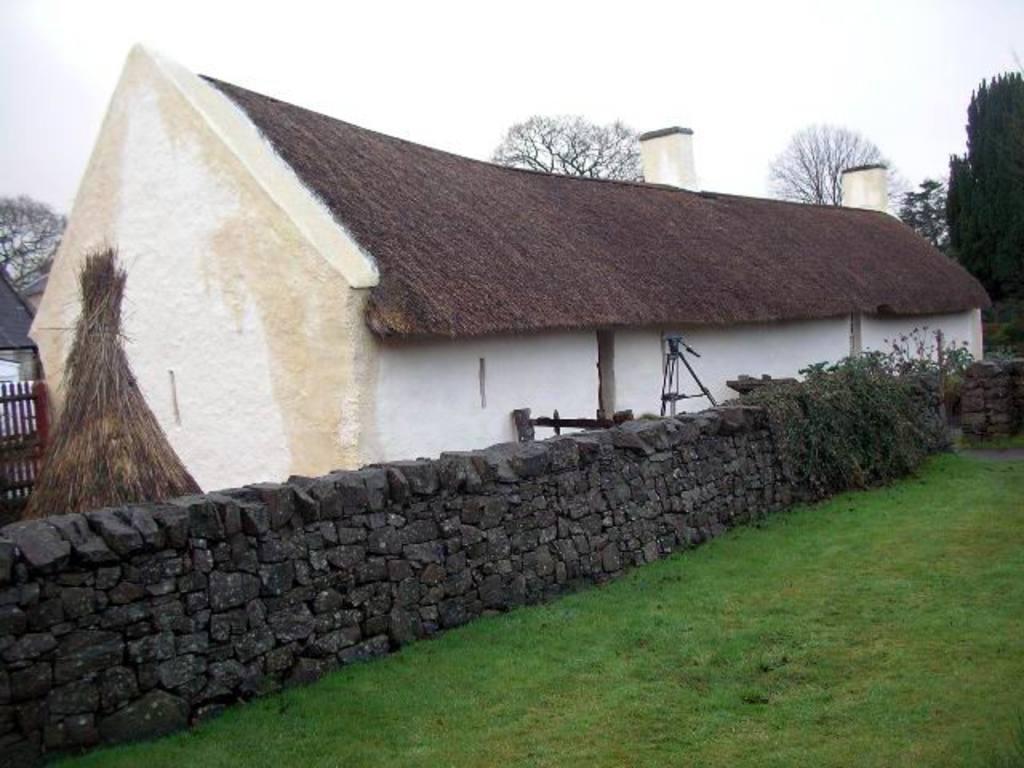Can you describe this image briefly? In this picture we can see some grass on the ground. There is some fencing, a house, a stone wall, trees and other objects. We can see the sky. 